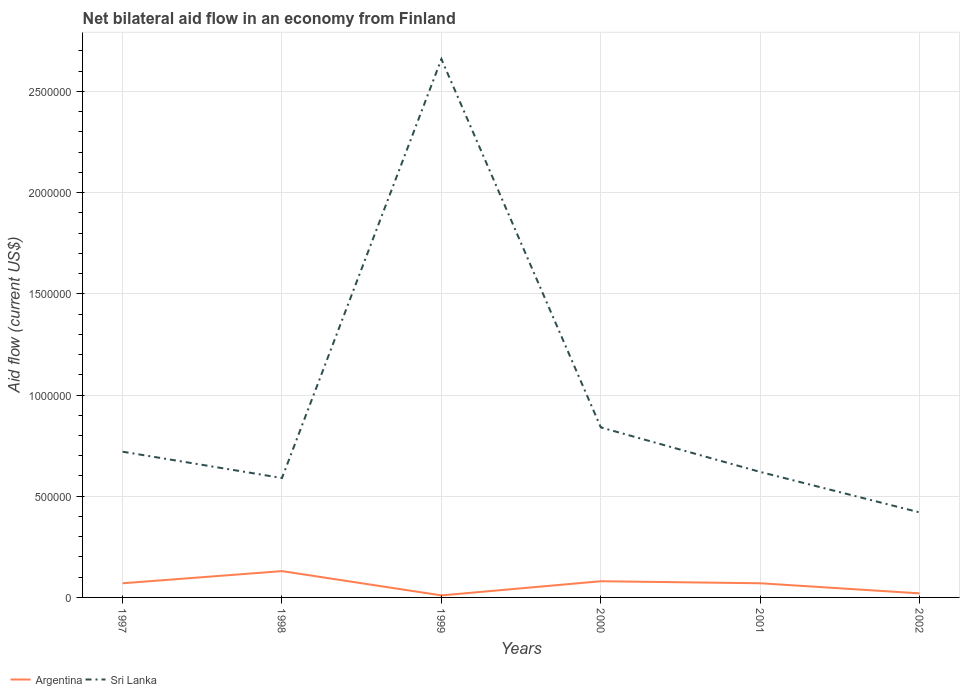Does the line corresponding to Sri Lanka intersect with the line corresponding to Argentina?
Provide a short and direct response. No. Is the number of lines equal to the number of legend labels?
Keep it short and to the point. Yes. What is the difference between the highest and the second highest net bilateral aid flow in Sri Lanka?
Offer a very short reply. 2.24e+06. What is the difference between the highest and the lowest net bilateral aid flow in Sri Lanka?
Keep it short and to the point. 1. Are the values on the major ticks of Y-axis written in scientific E-notation?
Provide a short and direct response. No. Where does the legend appear in the graph?
Offer a terse response. Bottom left. How are the legend labels stacked?
Offer a terse response. Horizontal. What is the title of the graph?
Your answer should be compact. Net bilateral aid flow in an economy from Finland. Does "Marshall Islands" appear as one of the legend labels in the graph?
Your answer should be compact. No. What is the Aid flow (current US$) of Argentina in 1997?
Your answer should be very brief. 7.00e+04. What is the Aid flow (current US$) of Sri Lanka in 1997?
Offer a terse response. 7.20e+05. What is the Aid flow (current US$) of Argentina in 1998?
Provide a short and direct response. 1.30e+05. What is the Aid flow (current US$) in Sri Lanka in 1998?
Provide a succinct answer. 5.90e+05. What is the Aid flow (current US$) of Sri Lanka in 1999?
Provide a succinct answer. 2.66e+06. What is the Aid flow (current US$) in Sri Lanka in 2000?
Your answer should be compact. 8.40e+05. What is the Aid flow (current US$) in Argentina in 2001?
Ensure brevity in your answer.  7.00e+04. What is the Aid flow (current US$) of Sri Lanka in 2001?
Give a very brief answer. 6.20e+05. Across all years, what is the maximum Aid flow (current US$) in Argentina?
Provide a short and direct response. 1.30e+05. Across all years, what is the maximum Aid flow (current US$) of Sri Lanka?
Offer a terse response. 2.66e+06. Across all years, what is the minimum Aid flow (current US$) in Argentina?
Your answer should be very brief. 10000. What is the total Aid flow (current US$) of Argentina in the graph?
Your answer should be compact. 3.80e+05. What is the total Aid flow (current US$) in Sri Lanka in the graph?
Keep it short and to the point. 5.85e+06. What is the difference between the Aid flow (current US$) of Sri Lanka in 1997 and that in 1998?
Provide a succinct answer. 1.30e+05. What is the difference between the Aid flow (current US$) in Argentina in 1997 and that in 1999?
Your answer should be very brief. 6.00e+04. What is the difference between the Aid flow (current US$) of Sri Lanka in 1997 and that in 1999?
Offer a very short reply. -1.94e+06. What is the difference between the Aid flow (current US$) of Argentina in 1997 and that in 2002?
Your answer should be very brief. 5.00e+04. What is the difference between the Aid flow (current US$) in Sri Lanka in 1997 and that in 2002?
Your answer should be compact. 3.00e+05. What is the difference between the Aid flow (current US$) in Sri Lanka in 1998 and that in 1999?
Your answer should be compact. -2.07e+06. What is the difference between the Aid flow (current US$) in Argentina in 1998 and that in 2000?
Provide a succinct answer. 5.00e+04. What is the difference between the Aid flow (current US$) in Sri Lanka in 1998 and that in 2000?
Offer a very short reply. -2.50e+05. What is the difference between the Aid flow (current US$) of Argentina in 1998 and that in 2001?
Your answer should be compact. 6.00e+04. What is the difference between the Aid flow (current US$) in Sri Lanka in 1999 and that in 2000?
Make the answer very short. 1.82e+06. What is the difference between the Aid flow (current US$) in Sri Lanka in 1999 and that in 2001?
Keep it short and to the point. 2.04e+06. What is the difference between the Aid flow (current US$) of Sri Lanka in 1999 and that in 2002?
Ensure brevity in your answer.  2.24e+06. What is the difference between the Aid flow (current US$) of Argentina in 2000 and that in 2001?
Make the answer very short. 10000. What is the difference between the Aid flow (current US$) of Argentina in 2001 and that in 2002?
Your answer should be compact. 5.00e+04. What is the difference between the Aid flow (current US$) of Sri Lanka in 2001 and that in 2002?
Provide a short and direct response. 2.00e+05. What is the difference between the Aid flow (current US$) of Argentina in 1997 and the Aid flow (current US$) of Sri Lanka in 1998?
Ensure brevity in your answer.  -5.20e+05. What is the difference between the Aid flow (current US$) of Argentina in 1997 and the Aid flow (current US$) of Sri Lanka in 1999?
Provide a succinct answer. -2.59e+06. What is the difference between the Aid flow (current US$) of Argentina in 1997 and the Aid flow (current US$) of Sri Lanka in 2000?
Provide a succinct answer. -7.70e+05. What is the difference between the Aid flow (current US$) of Argentina in 1997 and the Aid flow (current US$) of Sri Lanka in 2001?
Keep it short and to the point. -5.50e+05. What is the difference between the Aid flow (current US$) in Argentina in 1997 and the Aid flow (current US$) in Sri Lanka in 2002?
Keep it short and to the point. -3.50e+05. What is the difference between the Aid flow (current US$) in Argentina in 1998 and the Aid flow (current US$) in Sri Lanka in 1999?
Keep it short and to the point. -2.53e+06. What is the difference between the Aid flow (current US$) in Argentina in 1998 and the Aid flow (current US$) in Sri Lanka in 2000?
Keep it short and to the point. -7.10e+05. What is the difference between the Aid flow (current US$) of Argentina in 1998 and the Aid flow (current US$) of Sri Lanka in 2001?
Provide a succinct answer. -4.90e+05. What is the difference between the Aid flow (current US$) in Argentina in 1998 and the Aid flow (current US$) in Sri Lanka in 2002?
Ensure brevity in your answer.  -2.90e+05. What is the difference between the Aid flow (current US$) of Argentina in 1999 and the Aid flow (current US$) of Sri Lanka in 2000?
Your answer should be very brief. -8.30e+05. What is the difference between the Aid flow (current US$) in Argentina in 1999 and the Aid flow (current US$) in Sri Lanka in 2001?
Offer a terse response. -6.10e+05. What is the difference between the Aid flow (current US$) of Argentina in 1999 and the Aid flow (current US$) of Sri Lanka in 2002?
Ensure brevity in your answer.  -4.10e+05. What is the difference between the Aid flow (current US$) in Argentina in 2000 and the Aid flow (current US$) in Sri Lanka in 2001?
Your answer should be compact. -5.40e+05. What is the difference between the Aid flow (current US$) of Argentina in 2000 and the Aid flow (current US$) of Sri Lanka in 2002?
Keep it short and to the point. -3.40e+05. What is the difference between the Aid flow (current US$) of Argentina in 2001 and the Aid flow (current US$) of Sri Lanka in 2002?
Your response must be concise. -3.50e+05. What is the average Aid flow (current US$) in Argentina per year?
Give a very brief answer. 6.33e+04. What is the average Aid flow (current US$) in Sri Lanka per year?
Give a very brief answer. 9.75e+05. In the year 1997, what is the difference between the Aid flow (current US$) in Argentina and Aid flow (current US$) in Sri Lanka?
Your answer should be very brief. -6.50e+05. In the year 1998, what is the difference between the Aid flow (current US$) of Argentina and Aid flow (current US$) of Sri Lanka?
Provide a succinct answer. -4.60e+05. In the year 1999, what is the difference between the Aid flow (current US$) of Argentina and Aid flow (current US$) of Sri Lanka?
Give a very brief answer. -2.65e+06. In the year 2000, what is the difference between the Aid flow (current US$) of Argentina and Aid flow (current US$) of Sri Lanka?
Offer a terse response. -7.60e+05. In the year 2001, what is the difference between the Aid flow (current US$) of Argentina and Aid flow (current US$) of Sri Lanka?
Provide a short and direct response. -5.50e+05. In the year 2002, what is the difference between the Aid flow (current US$) of Argentina and Aid flow (current US$) of Sri Lanka?
Your response must be concise. -4.00e+05. What is the ratio of the Aid flow (current US$) in Argentina in 1997 to that in 1998?
Keep it short and to the point. 0.54. What is the ratio of the Aid flow (current US$) of Sri Lanka in 1997 to that in 1998?
Give a very brief answer. 1.22. What is the ratio of the Aid flow (current US$) in Sri Lanka in 1997 to that in 1999?
Give a very brief answer. 0.27. What is the ratio of the Aid flow (current US$) of Sri Lanka in 1997 to that in 2001?
Your answer should be compact. 1.16. What is the ratio of the Aid flow (current US$) of Argentina in 1997 to that in 2002?
Make the answer very short. 3.5. What is the ratio of the Aid flow (current US$) of Sri Lanka in 1997 to that in 2002?
Your answer should be very brief. 1.71. What is the ratio of the Aid flow (current US$) of Sri Lanka in 1998 to that in 1999?
Give a very brief answer. 0.22. What is the ratio of the Aid flow (current US$) of Argentina in 1998 to that in 2000?
Keep it short and to the point. 1.62. What is the ratio of the Aid flow (current US$) in Sri Lanka in 1998 to that in 2000?
Your answer should be very brief. 0.7. What is the ratio of the Aid flow (current US$) in Argentina in 1998 to that in 2001?
Provide a succinct answer. 1.86. What is the ratio of the Aid flow (current US$) in Sri Lanka in 1998 to that in 2001?
Offer a very short reply. 0.95. What is the ratio of the Aid flow (current US$) in Argentina in 1998 to that in 2002?
Keep it short and to the point. 6.5. What is the ratio of the Aid flow (current US$) of Sri Lanka in 1998 to that in 2002?
Offer a terse response. 1.4. What is the ratio of the Aid flow (current US$) of Argentina in 1999 to that in 2000?
Make the answer very short. 0.12. What is the ratio of the Aid flow (current US$) of Sri Lanka in 1999 to that in 2000?
Ensure brevity in your answer.  3.17. What is the ratio of the Aid flow (current US$) of Argentina in 1999 to that in 2001?
Keep it short and to the point. 0.14. What is the ratio of the Aid flow (current US$) in Sri Lanka in 1999 to that in 2001?
Keep it short and to the point. 4.29. What is the ratio of the Aid flow (current US$) in Argentina in 1999 to that in 2002?
Keep it short and to the point. 0.5. What is the ratio of the Aid flow (current US$) in Sri Lanka in 1999 to that in 2002?
Your answer should be very brief. 6.33. What is the ratio of the Aid flow (current US$) of Argentina in 2000 to that in 2001?
Ensure brevity in your answer.  1.14. What is the ratio of the Aid flow (current US$) in Sri Lanka in 2000 to that in 2001?
Your answer should be compact. 1.35. What is the ratio of the Aid flow (current US$) of Argentina in 2000 to that in 2002?
Your answer should be compact. 4. What is the ratio of the Aid flow (current US$) of Sri Lanka in 2000 to that in 2002?
Keep it short and to the point. 2. What is the ratio of the Aid flow (current US$) of Argentina in 2001 to that in 2002?
Ensure brevity in your answer.  3.5. What is the ratio of the Aid flow (current US$) in Sri Lanka in 2001 to that in 2002?
Keep it short and to the point. 1.48. What is the difference between the highest and the second highest Aid flow (current US$) of Sri Lanka?
Ensure brevity in your answer.  1.82e+06. What is the difference between the highest and the lowest Aid flow (current US$) of Argentina?
Your answer should be compact. 1.20e+05. What is the difference between the highest and the lowest Aid flow (current US$) in Sri Lanka?
Your answer should be compact. 2.24e+06. 